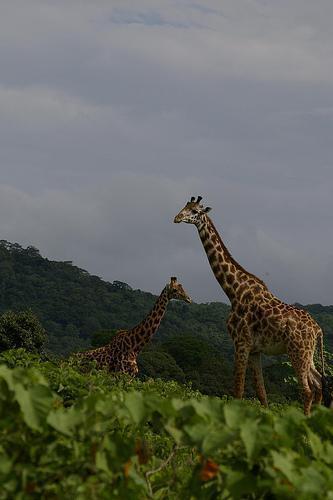How many giraffes are in this picture?
Give a very brief answer. 2. How many ears do they have?
Give a very brief answer. 2. How many green giraffe are there?
Give a very brief answer. 0. 